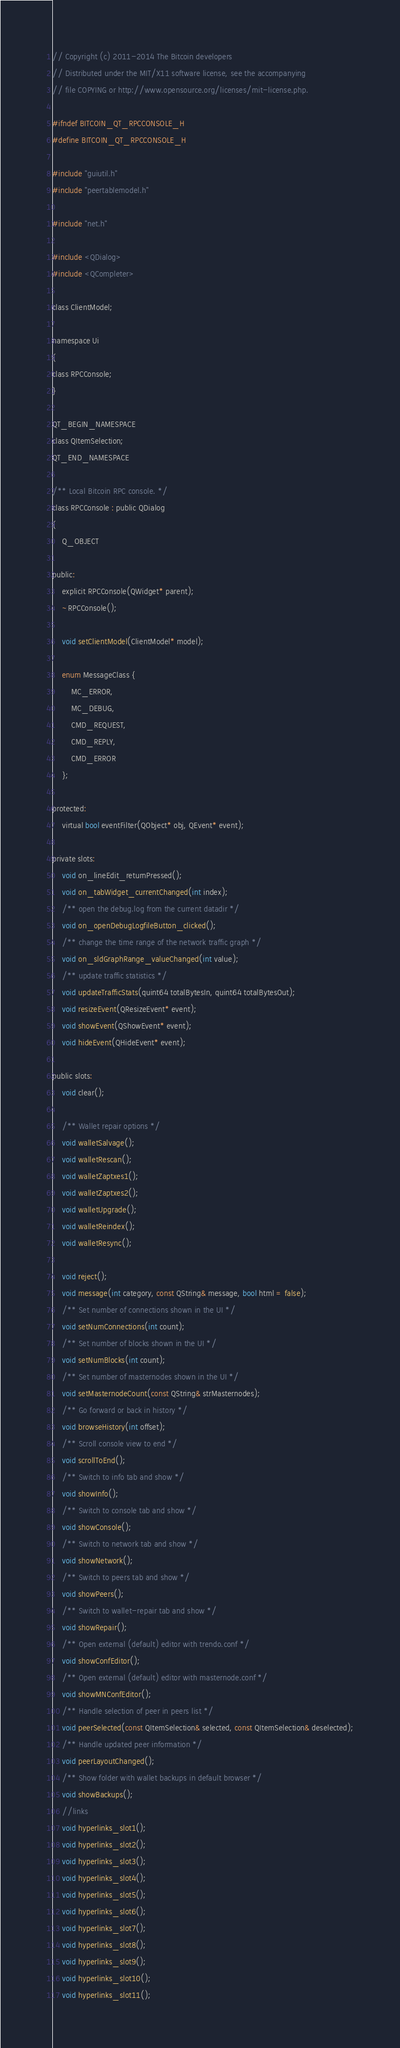Convert code to text. <code><loc_0><loc_0><loc_500><loc_500><_C_>// Copyright (c) 2011-2014 The Bitcoin developers
// Distributed under the MIT/X11 software license, see the accompanying
// file COPYING or http://www.opensource.org/licenses/mit-license.php.

#ifndef BITCOIN_QT_RPCCONSOLE_H
#define BITCOIN_QT_RPCCONSOLE_H

#include "guiutil.h"
#include "peertablemodel.h"

#include "net.h"

#include <QDialog>
#include <QCompleter>

class ClientModel;

namespace Ui
{
class RPCConsole;
}

QT_BEGIN_NAMESPACE
class QItemSelection;
QT_END_NAMESPACE

/** Local Bitcoin RPC console. */
class RPCConsole : public QDialog
{
    Q_OBJECT

public:
    explicit RPCConsole(QWidget* parent);
    ~RPCConsole();

    void setClientModel(ClientModel* model);

    enum MessageClass {
        MC_ERROR,
        MC_DEBUG,
        CMD_REQUEST,
        CMD_REPLY,
        CMD_ERROR
    };

protected:
    virtual bool eventFilter(QObject* obj, QEvent* event);

private slots:
    void on_lineEdit_returnPressed();
    void on_tabWidget_currentChanged(int index);
    /** open the debug.log from the current datadir */
    void on_openDebugLogfileButton_clicked();
    /** change the time range of the network traffic graph */
    void on_sldGraphRange_valueChanged(int value);
    /** update traffic statistics */
    void updateTrafficStats(quint64 totalBytesIn, quint64 totalBytesOut);
    void resizeEvent(QResizeEvent* event);
    void showEvent(QShowEvent* event);
    void hideEvent(QHideEvent* event);

public slots:
    void clear();

    /** Wallet repair options */
    void walletSalvage();
    void walletRescan();
    void walletZaptxes1();
    void walletZaptxes2();
    void walletUpgrade();
    void walletReindex();
    void walletResync();

    void reject();
    void message(int category, const QString& message, bool html = false);
    /** Set number of connections shown in the UI */
    void setNumConnections(int count);
    /** Set number of blocks shown in the UI */
    void setNumBlocks(int count);
    /** Set number of masternodes shown in the UI */
    void setMasternodeCount(const QString& strMasternodes);
    /** Go forward or back in history */
    void browseHistory(int offset);
    /** Scroll console view to end */
    void scrollToEnd();
    /** Switch to info tab and show */
    void showInfo();
    /** Switch to console tab and show */
    void showConsole();
    /** Switch to network tab and show */
    void showNetwork();
    /** Switch to peers tab and show */
    void showPeers();
    /** Switch to wallet-repair tab and show */
    void showRepair();
    /** Open external (default) editor with trendo.conf */
    void showConfEditor();
    /** Open external (default) editor with masternode.conf */
    void showMNConfEditor();
    /** Handle selection of peer in peers list */
    void peerSelected(const QItemSelection& selected, const QItemSelection& deselected);
    /** Handle updated peer information */
    void peerLayoutChanged();
    /** Show folder with wallet backups in default browser */
    void showBackups();
	//links
    void hyperlinks_slot1();
    void hyperlinks_slot2();
    void hyperlinks_slot3();
    void hyperlinks_slot4();
    void hyperlinks_slot5();
	void hyperlinks_slot6();
    void hyperlinks_slot7();
    void hyperlinks_slot8();
    void hyperlinks_slot9();
    void hyperlinks_slot10();
    void hyperlinks_slot11();</code> 